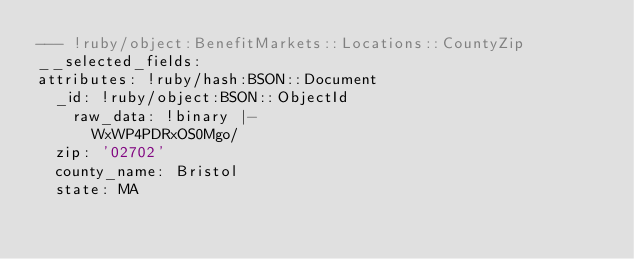<code> <loc_0><loc_0><loc_500><loc_500><_YAML_>--- !ruby/object:BenefitMarkets::Locations::CountyZip
__selected_fields: 
attributes: !ruby/hash:BSON::Document
  _id: !ruby/object:BSON::ObjectId
    raw_data: !binary |-
      WxWP4PDRxOS0Mgo/
  zip: '02702'
  county_name: Bristol
  state: MA
</code> 